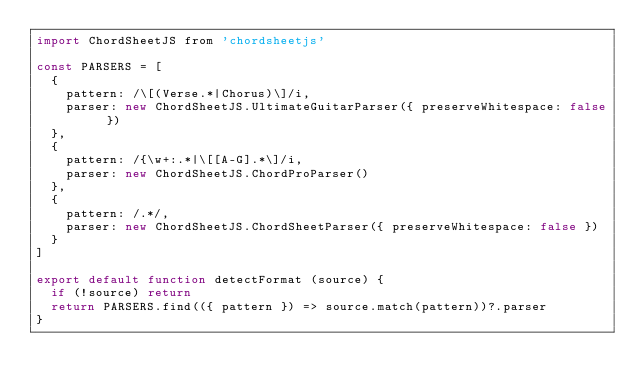Convert code to text. <code><loc_0><loc_0><loc_500><loc_500><_JavaScript_>import ChordSheetJS from 'chordsheetjs'

const PARSERS = [
  {
    pattern: /\[(Verse.*|Chorus)\]/i,
    parser: new ChordSheetJS.UltimateGuitarParser({ preserveWhitespace: false })
  },
  {
    pattern: /{\w+:.*|\[[A-G].*\]/i,
    parser: new ChordSheetJS.ChordProParser()
  },
  {
    pattern: /.*/,
    parser: new ChordSheetJS.ChordSheetParser({ preserveWhitespace: false })
  }
]

export default function detectFormat (source) {
  if (!source) return
  return PARSERS.find(({ pattern }) => source.match(pattern))?.parser
}
</code> 